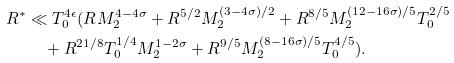Convert formula to latex. <formula><loc_0><loc_0><loc_500><loc_500>R ^ { * } & \ll T _ { 0 } ^ { 4 \epsilon } ( R M _ { 2 } ^ { 4 - 4 \sigma } + R ^ { 5 / 2 } M _ { 2 } ^ { ( 3 - 4 \sigma ) / 2 } + R ^ { 8 / 5 } M _ { 2 } ^ { ( 1 2 - 1 6 \sigma ) / 5 } T _ { 0 } ^ { 2 / 5 } \\ & \quad + R ^ { 2 1 / 8 } T _ { 0 } ^ { 1 / 4 } M _ { 2 } ^ { 1 - 2 \sigma } + R ^ { 9 / 5 } M _ { 2 } ^ { ( 8 - 1 6 \sigma ) / 5 } T _ { 0 } ^ { 4 / 5 } ) .</formula> 